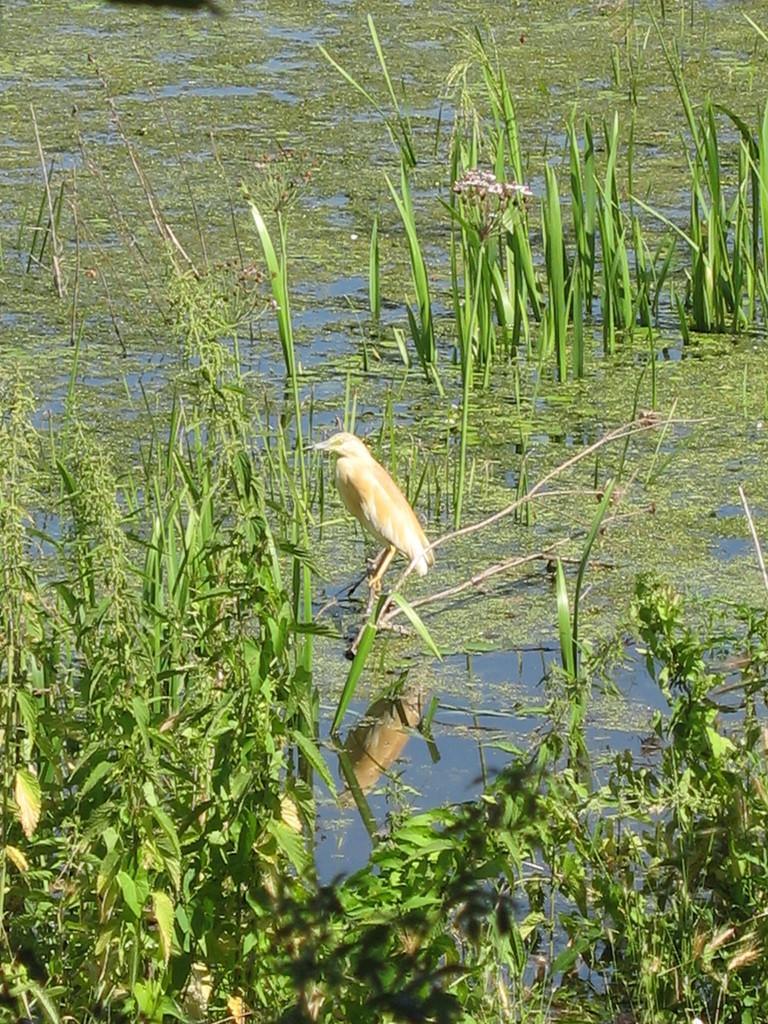Describe this image in one or two sentences. In the image we can see there is a bird standing on the plant and the ground is covered with water and plants. 